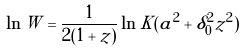<formula> <loc_0><loc_0><loc_500><loc_500>\ln W = \frac { 1 } { 2 ( 1 + z ) } \ln K ( a ^ { 2 } + \delta _ { 0 } ^ { 2 } { z } ^ { 2 } )</formula> 